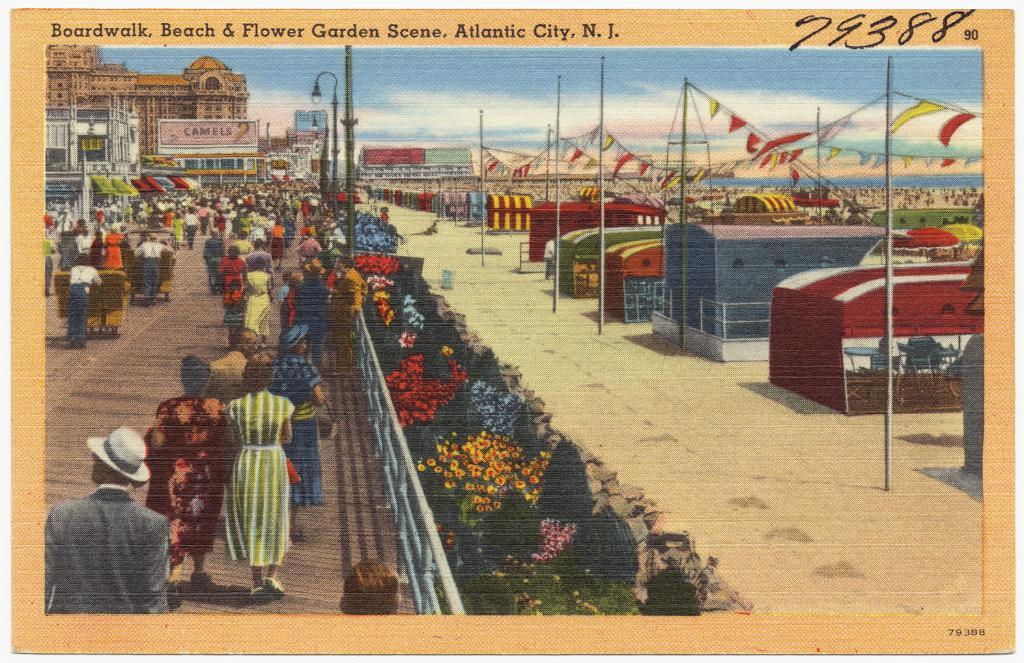<image>
Offer a succinct explanation of the picture presented. Art picture of a boardwalk, beach, and flower garden scene 